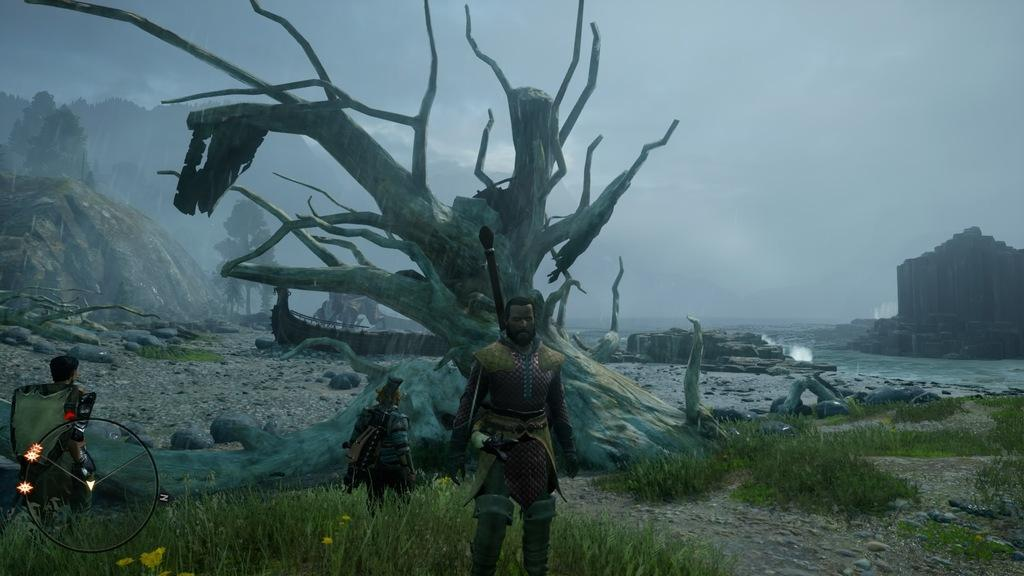What type of image is being described? The image is animated. Can you describe the people in the image? The people in the image are carrying something. What is the ground made of in the image? There is grass on the ground in the image. What can be seen in the background of the image? There are trees, rocks, and the sky visible in the background of the image. What unit of measurement is being used to weigh the basket in the image? There is no basket present in the image, so it is not possible to determine the unit of measurement being used to weigh it. 